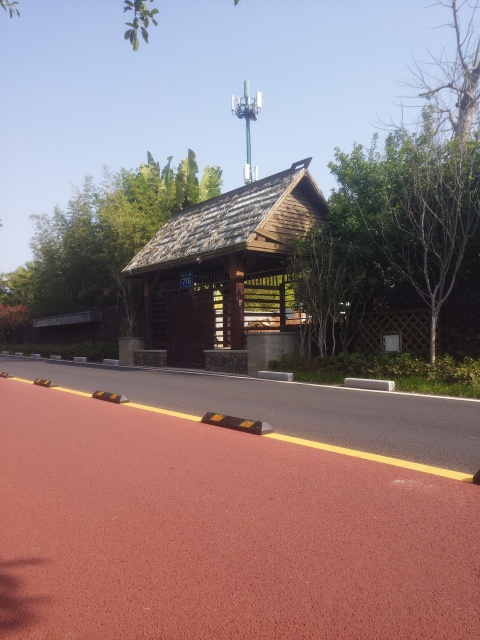Are there any environmental or technological elements present in this image? Yes, there's a juxtaposition of natural elements, such as the trees and the small rustic pavilion, with technological aspects, particularly the tall cell tower standing in the background against the sky, indicating the integration of technology with the environment. 